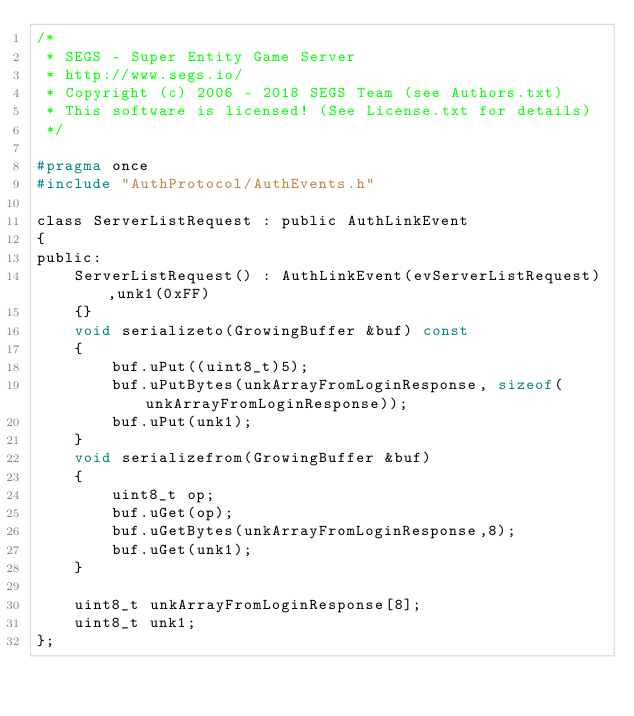Convert code to text. <code><loc_0><loc_0><loc_500><loc_500><_C_>/*
 * SEGS - Super Entity Game Server
 * http://www.segs.io/
 * Copyright (c) 2006 - 2018 SEGS Team (see Authors.txt)
 * This software is licensed! (See License.txt for details)
 */

#pragma once
#include "AuthProtocol/AuthEvents.h"

class ServerListRequest : public AuthLinkEvent
{
public:
    ServerListRequest() : AuthLinkEvent(evServerListRequest),unk1(0xFF)
    {}
    void serializeto(GrowingBuffer &buf) const
    {
        buf.uPut((uint8_t)5);
        buf.uPutBytes(unkArrayFromLoginResponse, sizeof(unkArrayFromLoginResponse));
        buf.uPut(unk1);
    }
    void serializefrom(GrowingBuffer &buf)
    {
        uint8_t op;
        buf.uGet(op);
        buf.uGetBytes(unkArrayFromLoginResponse,8);
        buf.uGet(unk1);
    }

    uint8_t unkArrayFromLoginResponse[8];
    uint8_t unk1;
};
</code> 